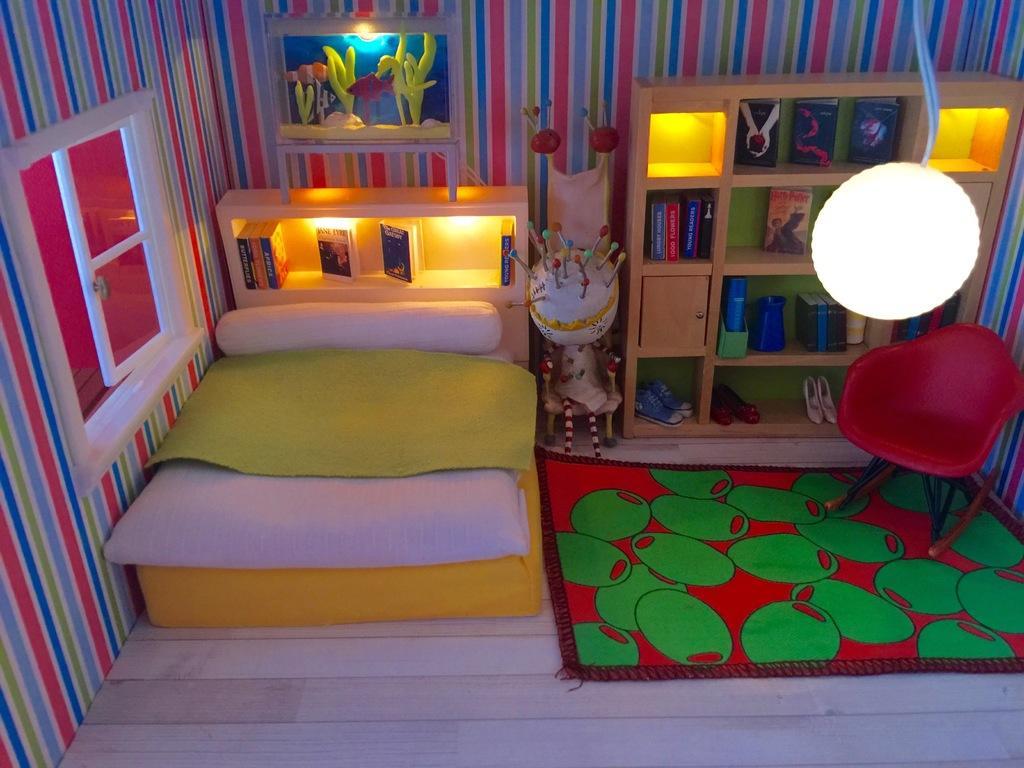Could you give a brief overview of what you see in this image? This image is clicked in a room. There is a bed, pillow, bookshelves, window. There is a light on the top. There is a chair on the left side. There are books in bookshelves. 